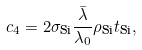<formula> <loc_0><loc_0><loc_500><loc_500>c _ { 4 } = 2 \sigma _ { \text {Si} } \frac { \bar { \lambda } } { \lambda _ { 0 } } \rho _ { \text {Si} } t _ { \text {Si} } ,</formula> 